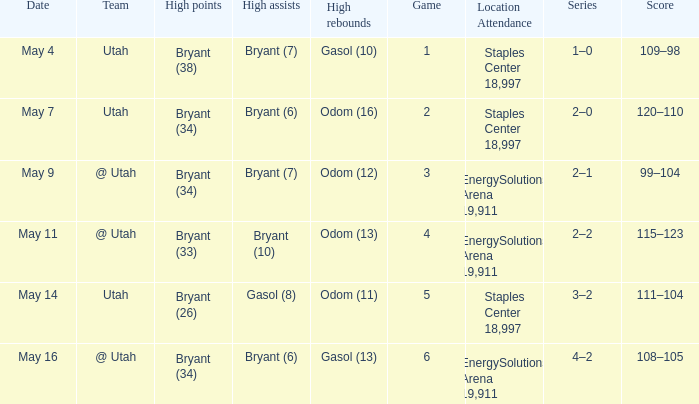What is the High rebounds with a Series with 4–2? Gasol (13). 